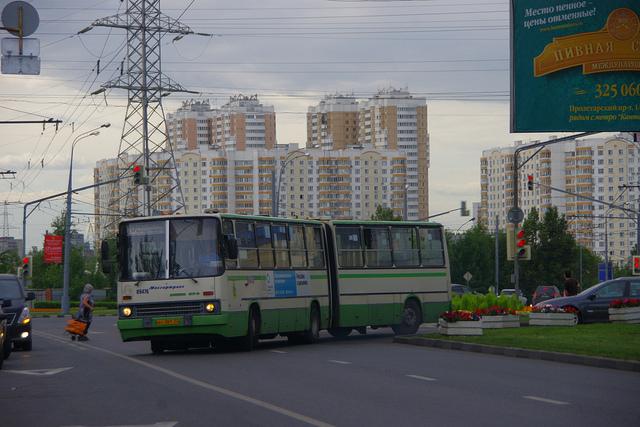Does this city bus usually pick up many people?
Give a very brief answer. Yes. Is the bus a double-decker?
Quick response, please. No. Is it daytime?
Concise answer only. Yes. Is there a turning lane?
Give a very brief answer. No. What city is this?
Short answer required. Moscow. What kind of weather it is?
Answer briefly. Cloudy. What is the number on the bus?
Short answer required. 8425. Does this bus go to Canada?
Short answer required. No. What type of bus is this?
Answer briefly. City. Is this bus stationary in the parking lot?
Keep it brief. No. Are the traffic lights red?
Write a very short answer. Yes. What color are the balconies on the high-rise?
Write a very short answer. White. What does the green sign on the right say?
Quick response, please. Nothing. How many cars does the train Offer?
Be succinct. 2. Where is the bus going?
Be succinct. Downtown. What color is the stripe going down the middle of the street?
Quick response, please. White. How many levels does the bus have?
Answer briefly. 1. Are the bus's front lights on?
Short answer required. Yes. How does this driver not see the buses meeting him head-on?
Keep it brief. Not looking. Where are the people walking too?
Answer briefly. Bus. Is this vehicle powered by those power lines?
Be succinct. No. How many buses on the road?
Quick response, please. 1. Is the bus on the crosswalk?
Short answer required. No. Are there few or many cars?
Be succinct. Few. Is this a sunny day?
Short answer required. No. Is there a raised curb on the road?
Be succinct. Yes. What color are the tall flowers in the front?
Concise answer only. Red. What kind of tree is on the corner?
Answer briefly. Pine tree. Are the car's headlights illuminated?
Answer briefly. Yes. What is on the tower?
Short answer required. Power lines. What does green mean?
Write a very short answer. Go. What color is the bus?
Answer briefly. White and green. 